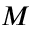Convert formula to latex. <formula><loc_0><loc_0><loc_500><loc_500>M</formula> 